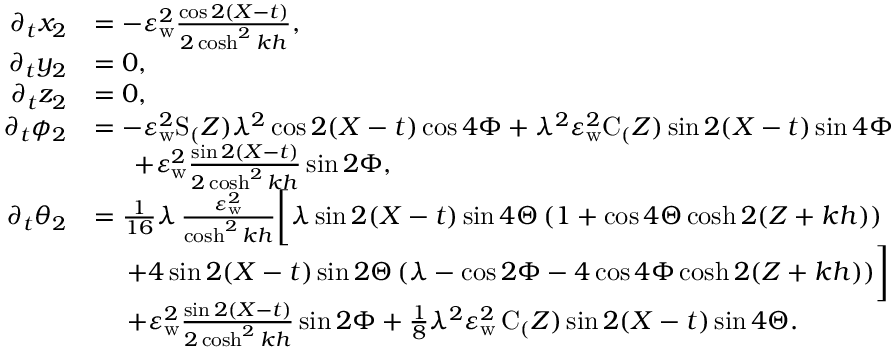<formula> <loc_0><loc_0><loc_500><loc_500>\begin{array} { r l } { \partial _ { t } x _ { 2 } } & { = - \varepsilon _ { w } ^ { 2 } \frac { \cos 2 ( X - t ) } { 2 \cosh ^ { 2 } k h } , } \\ { \partial _ { t } y _ { 2 } } & { = 0 , } \\ { \partial _ { t } z _ { 2 } } & { = 0 , } \\ { \partial _ { t } { \phi _ { 2 } } } & { = - \varepsilon _ { w } ^ { 2 } S _ { ( } Z ) \lambda ^ { 2 } \cos 2 ( X - t ) \cos { 4 \Phi } + \lambda ^ { 2 } \varepsilon _ { w } ^ { 2 } C _ { ( } Z ) \sin 2 ( X - t ) \sin { 4 \Phi } } \\ & { \quad \, + \varepsilon _ { w } ^ { 2 } \frac { \sin 2 ( X - t ) } { 2 \cosh ^ { 2 } k h } \sin { 2 \Phi } , } \\ { \partial _ { t } { \theta _ { 2 } } } & { = \frac { 1 } { 1 6 } \lambda \, \frac { \varepsilon _ { w } ^ { 2 } } { \cosh ^ { 2 } k h } \left [ \lambda \sin 2 ( X - t ) \sin { 4 \Theta } \, ( 1 + \cos { 4 \Theta } \cosh 2 ( Z + k h ) ) } \\ & { \quad \, + 4 \sin 2 ( X - t ) \sin { 2 \Theta } \, ( \lambda - \cos { 2 \Phi } - 4 \cos { 4 \Phi } \cosh 2 ( Z + k h ) ) \right ] } \\ & { \quad \, + \varepsilon _ { w } ^ { 2 } \frac { \sin 2 ( X - t ) } { 2 \cosh ^ { 2 } k h } \sin { 2 \Phi } + \frac { 1 } { 8 } \lambda ^ { 2 } \varepsilon _ { w } ^ { 2 } \, C _ { ( } Z ) \sin 2 ( X - t ) \sin { 4 \Theta } . } \end{array}</formula> 